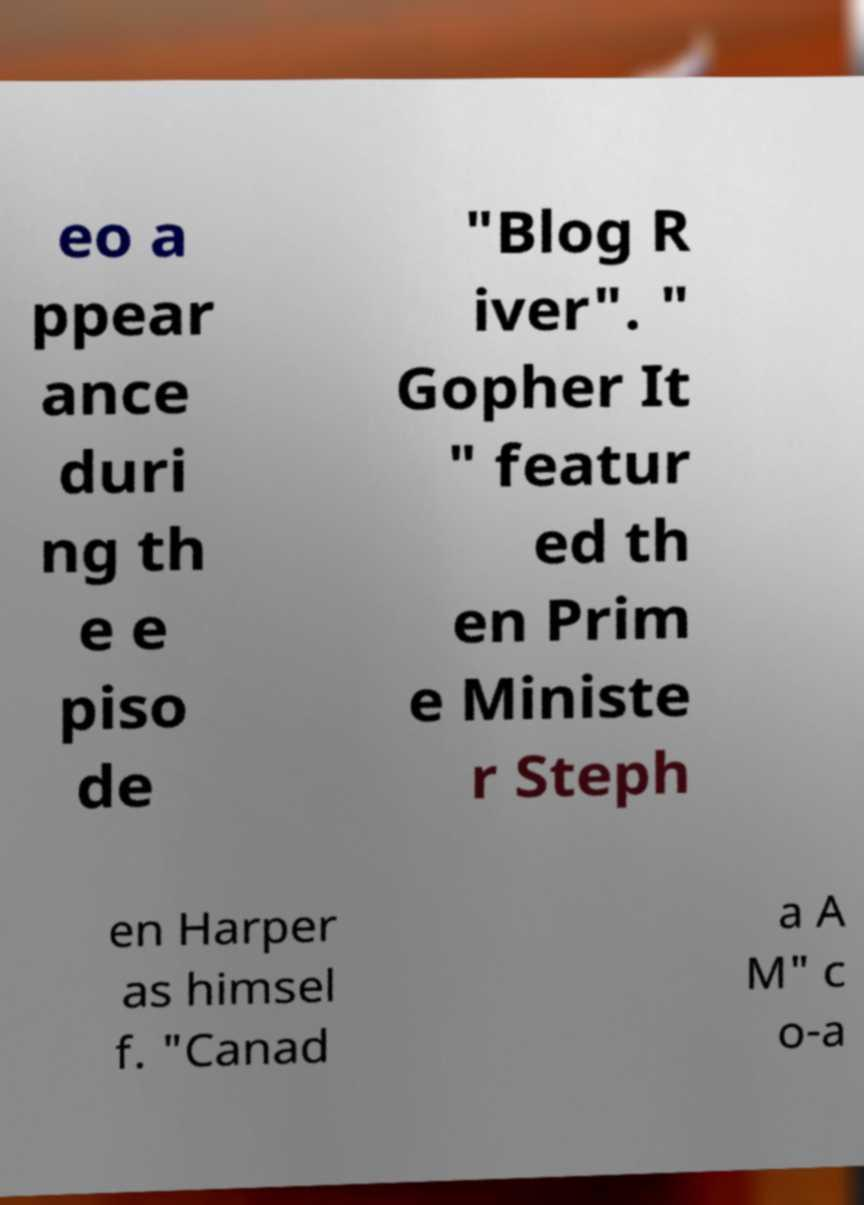Could you assist in decoding the text presented in this image and type it out clearly? eo a ppear ance duri ng th e e piso de "Blog R iver". " Gopher It " featur ed th en Prim e Ministe r Steph en Harper as himsel f. "Canad a A M" c o-a 